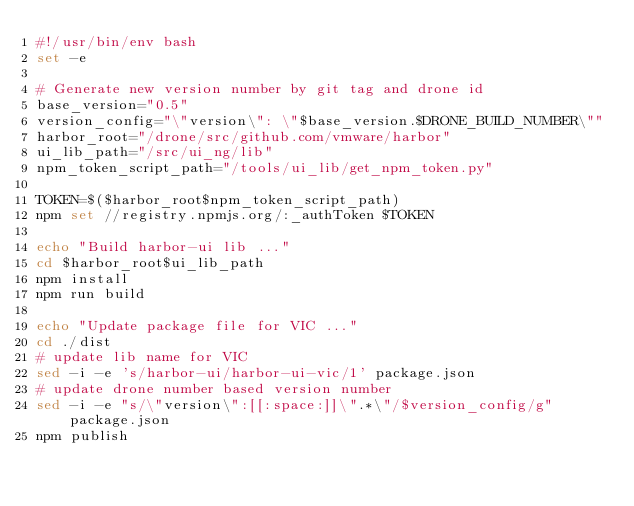Convert code to text. <code><loc_0><loc_0><loc_500><loc_500><_Bash_>#!/usr/bin/env bash
set -e

# Generate new version number by git tag and drone id
base_version="0.5"
version_config="\"version\": \"$base_version.$DRONE_BUILD_NUMBER\""
harbor_root="/drone/src/github.com/vmware/harbor"
ui_lib_path="/src/ui_ng/lib"
npm_token_script_path="/tools/ui_lib/get_npm_token.py"

TOKEN=$($harbor_root$npm_token_script_path)
npm set //registry.npmjs.org/:_authToken $TOKEN

echo "Build harbor-ui lib ..."
cd $harbor_root$ui_lib_path
npm install
npm run build

echo "Update package file for VIC ..."
cd ./dist
# update lib name for VIC
sed -i -e 's/harbor-ui/harbor-ui-vic/1' package.json
# update drone number based version number 
sed -i -e "s/\"version\":[[:space:]]\".*\"/$version_config/g" package.json
npm publish</code> 